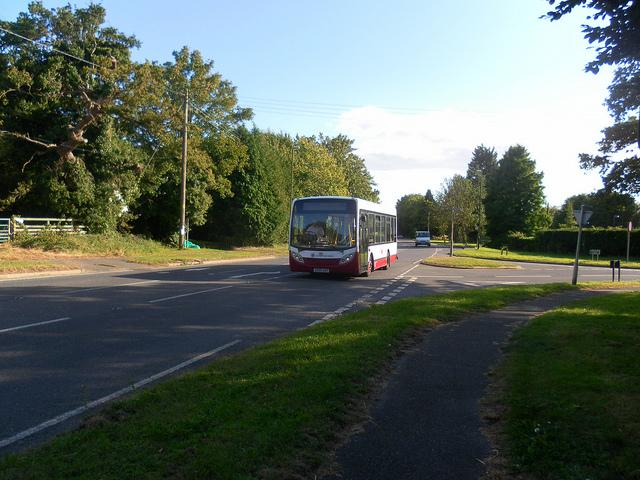Why is the windshield on the bus so large? Please explain your reasoning. visibility. So the driver can see all around them. 